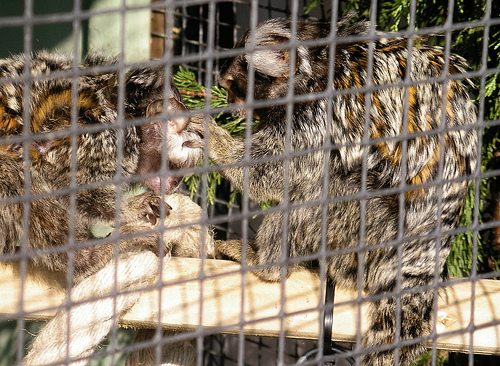<image>
Is the animal on the rope? Yes. Looking at the image, I can see the animal is positioned on top of the rope, with the rope providing support. 